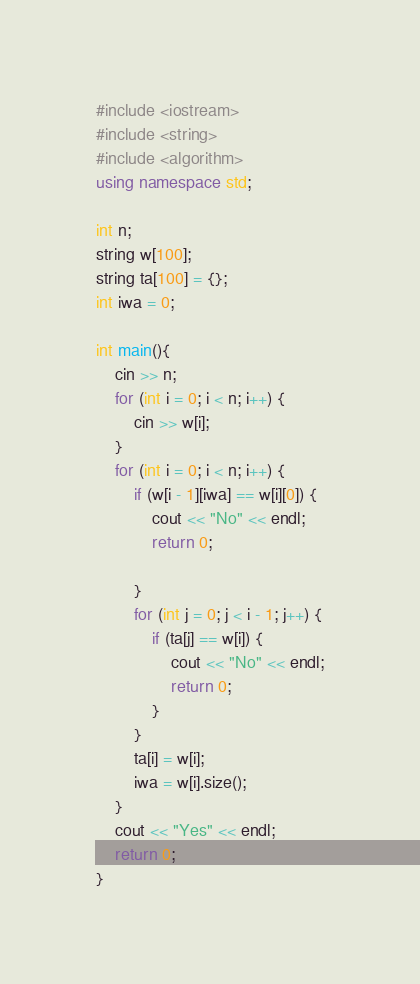<code> <loc_0><loc_0><loc_500><loc_500><_C++_>#include <iostream>
#include <string>
#include <algorithm>
using namespace std;

int n;
string w[100];
string ta[100] = {};
int iwa = 0;

int main(){
	cin >> n;
	for (int i = 0; i < n; i++) {
		cin >> w[i];
	}
	for (int i = 0; i < n; i++) {
		if (w[i - 1][iwa] == w[i][0]) {
			cout << "No" << endl;
			return 0;
			
		}
		for (int j = 0; j < i - 1; j++) {
			if (ta[j] == w[i]) {
				cout << "No" << endl;
				return 0;
			}
		}
		ta[i] = w[i];
		iwa = w[i].size();
	}
	cout << "Yes" << endl;
	return 0;
}
</code> 